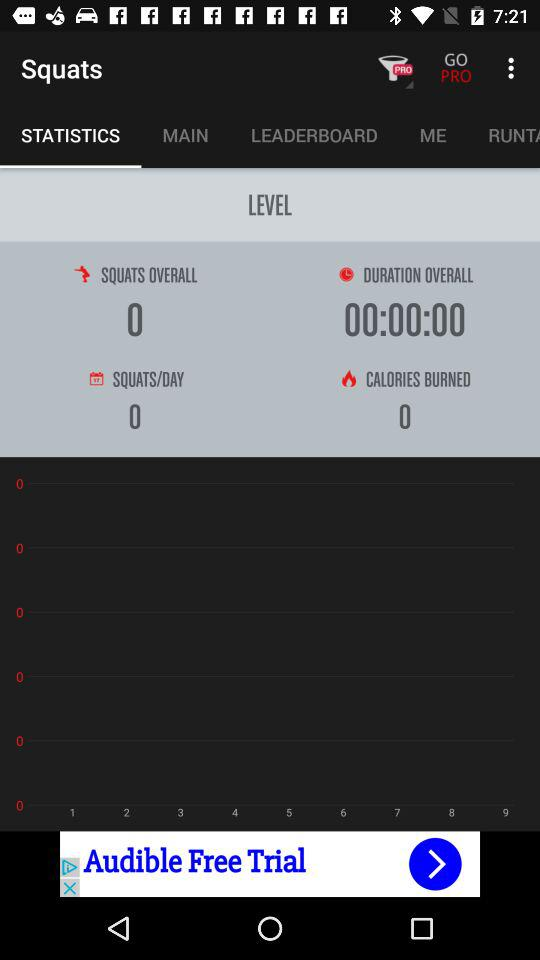What is the total number of squads per day shown in the application? The total number of squads per day shown in the application is 0. 